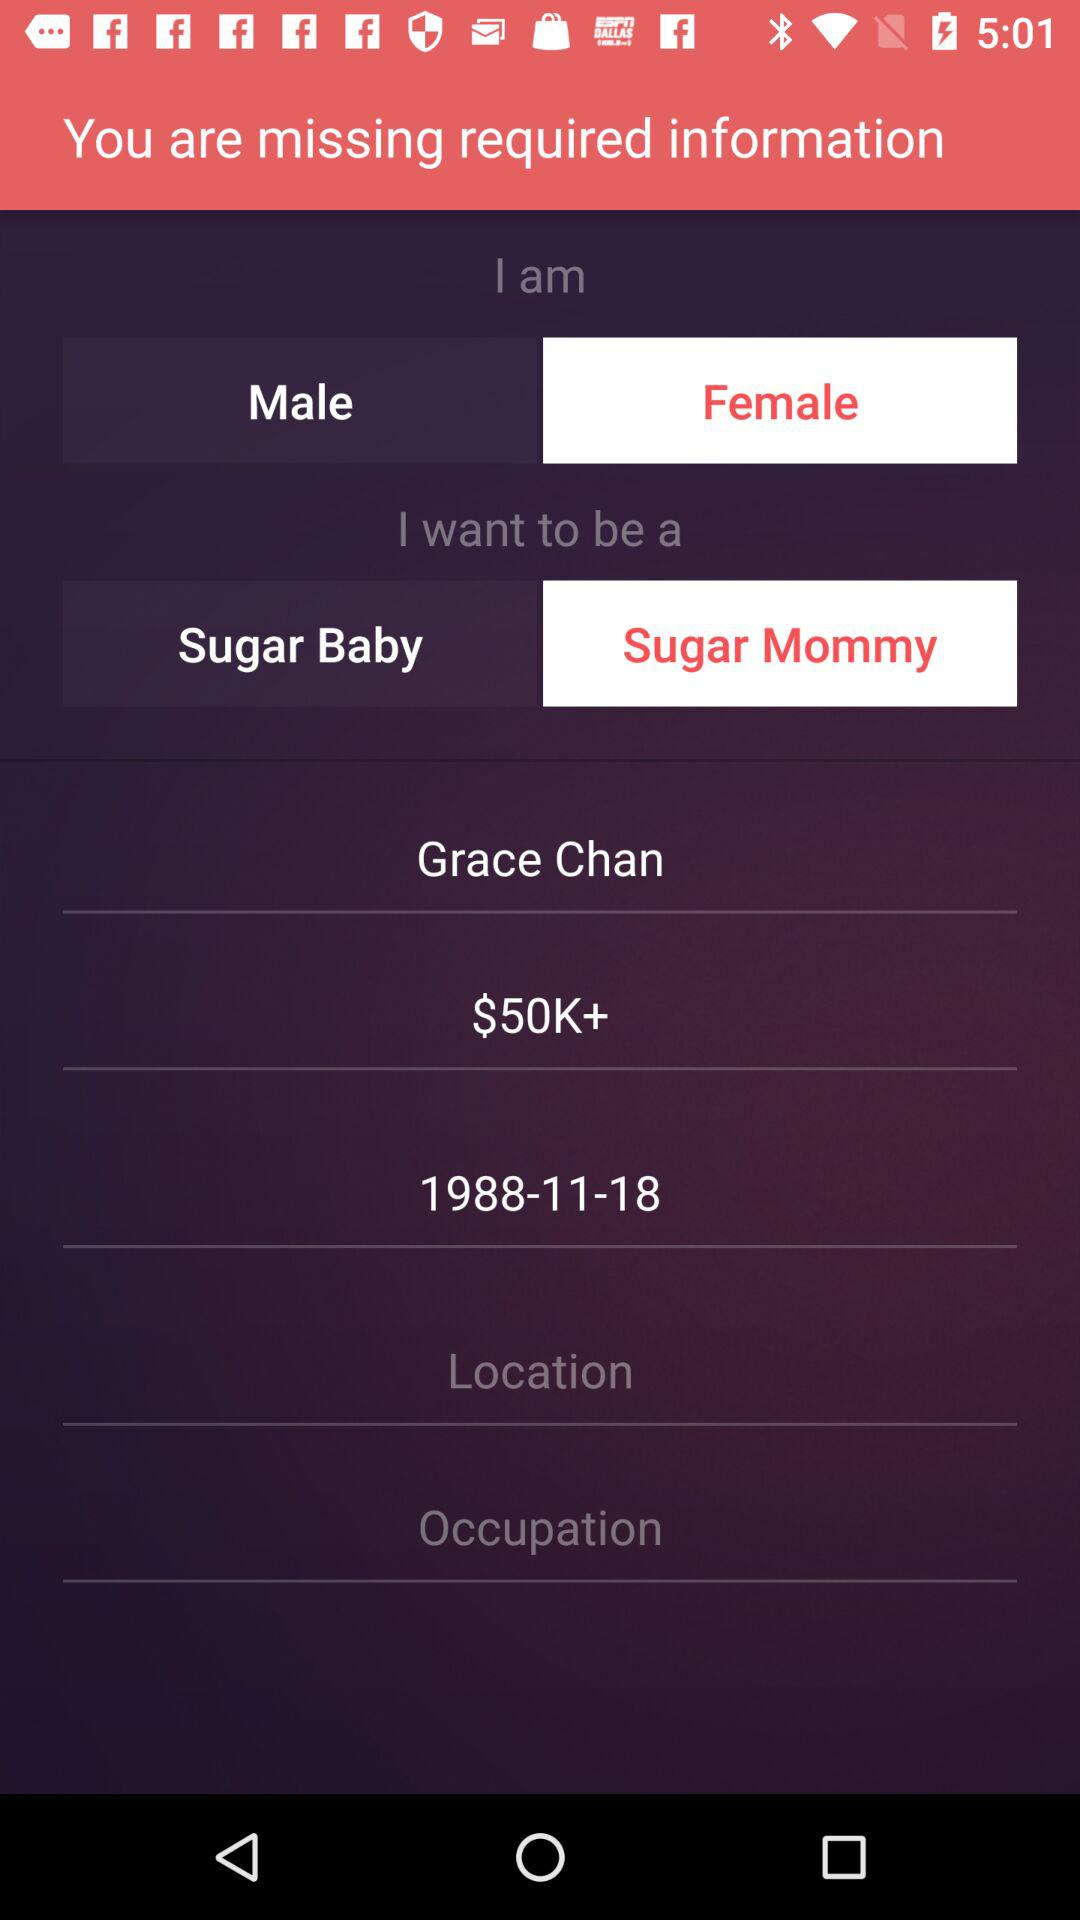What is the user name? The user name is Grace Chan. 